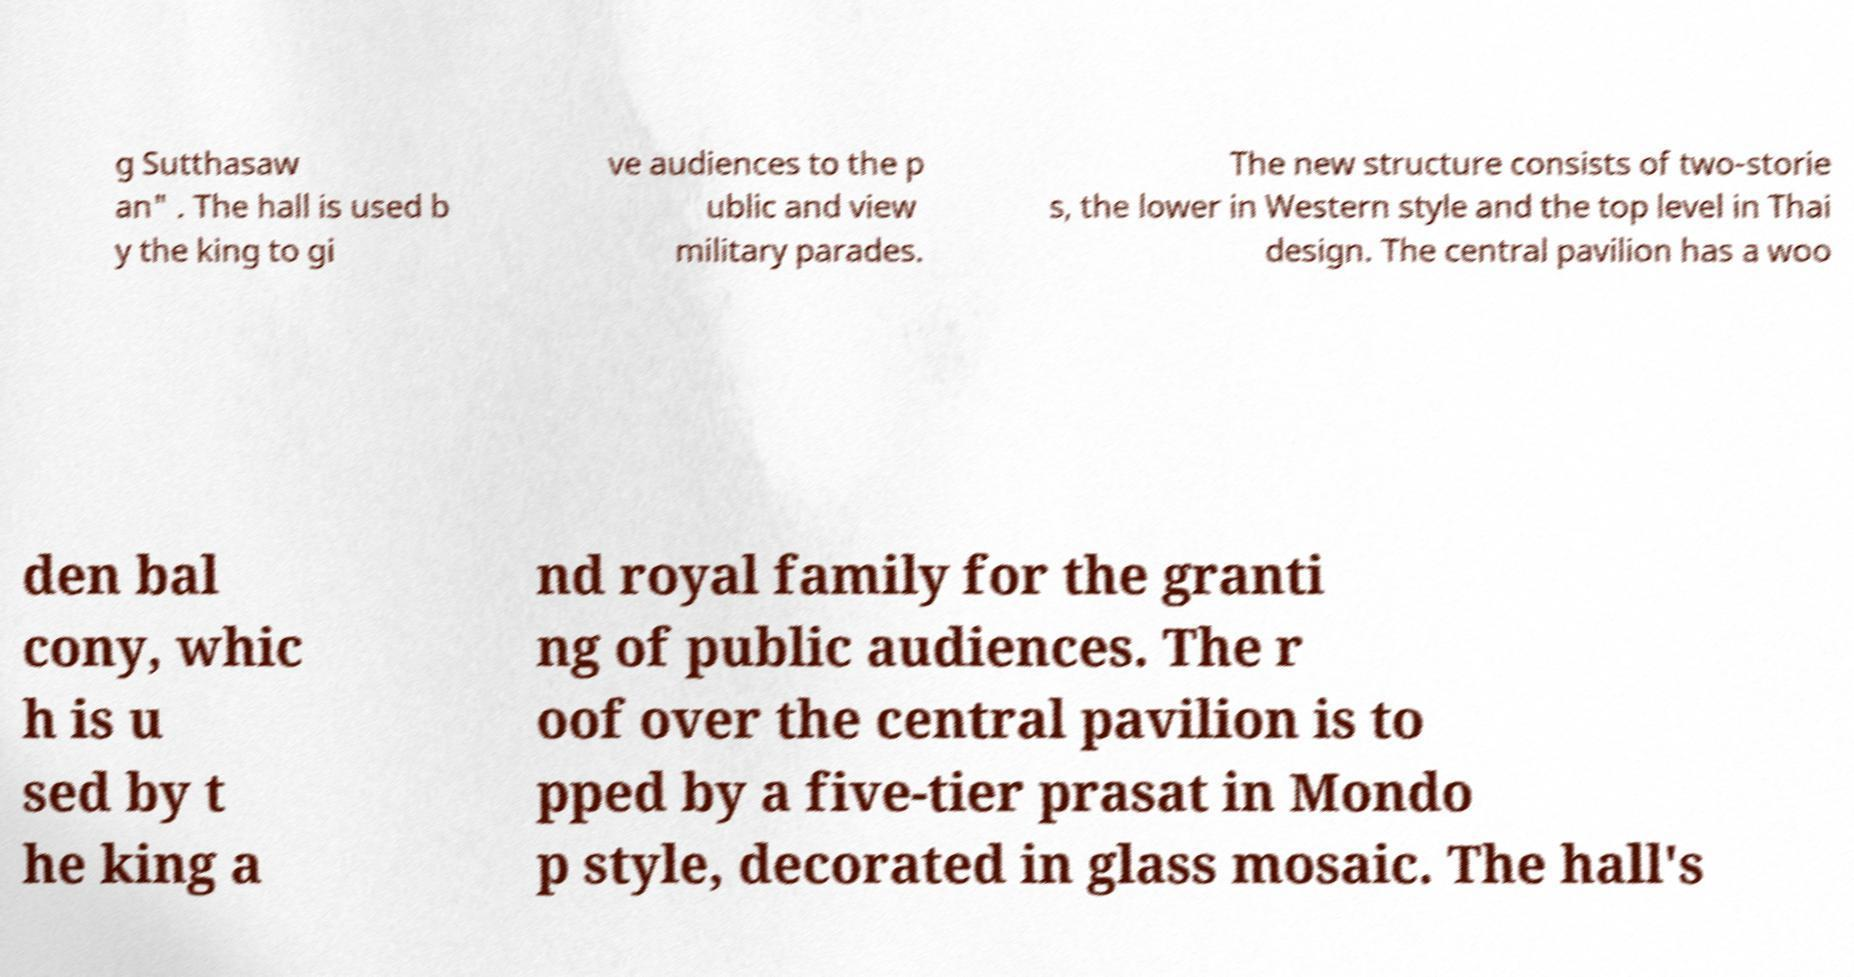Can you accurately transcribe the text from the provided image for me? g Sutthasaw an" . The hall is used b y the king to gi ve audiences to the p ublic and view military parades. The new structure consists of two-storie s, the lower in Western style and the top level in Thai design. The central pavilion has a woo den bal cony, whic h is u sed by t he king a nd royal family for the granti ng of public audiences. The r oof over the central pavilion is to pped by a five-tier prasat in Mondo p style, decorated in glass mosaic. The hall's 